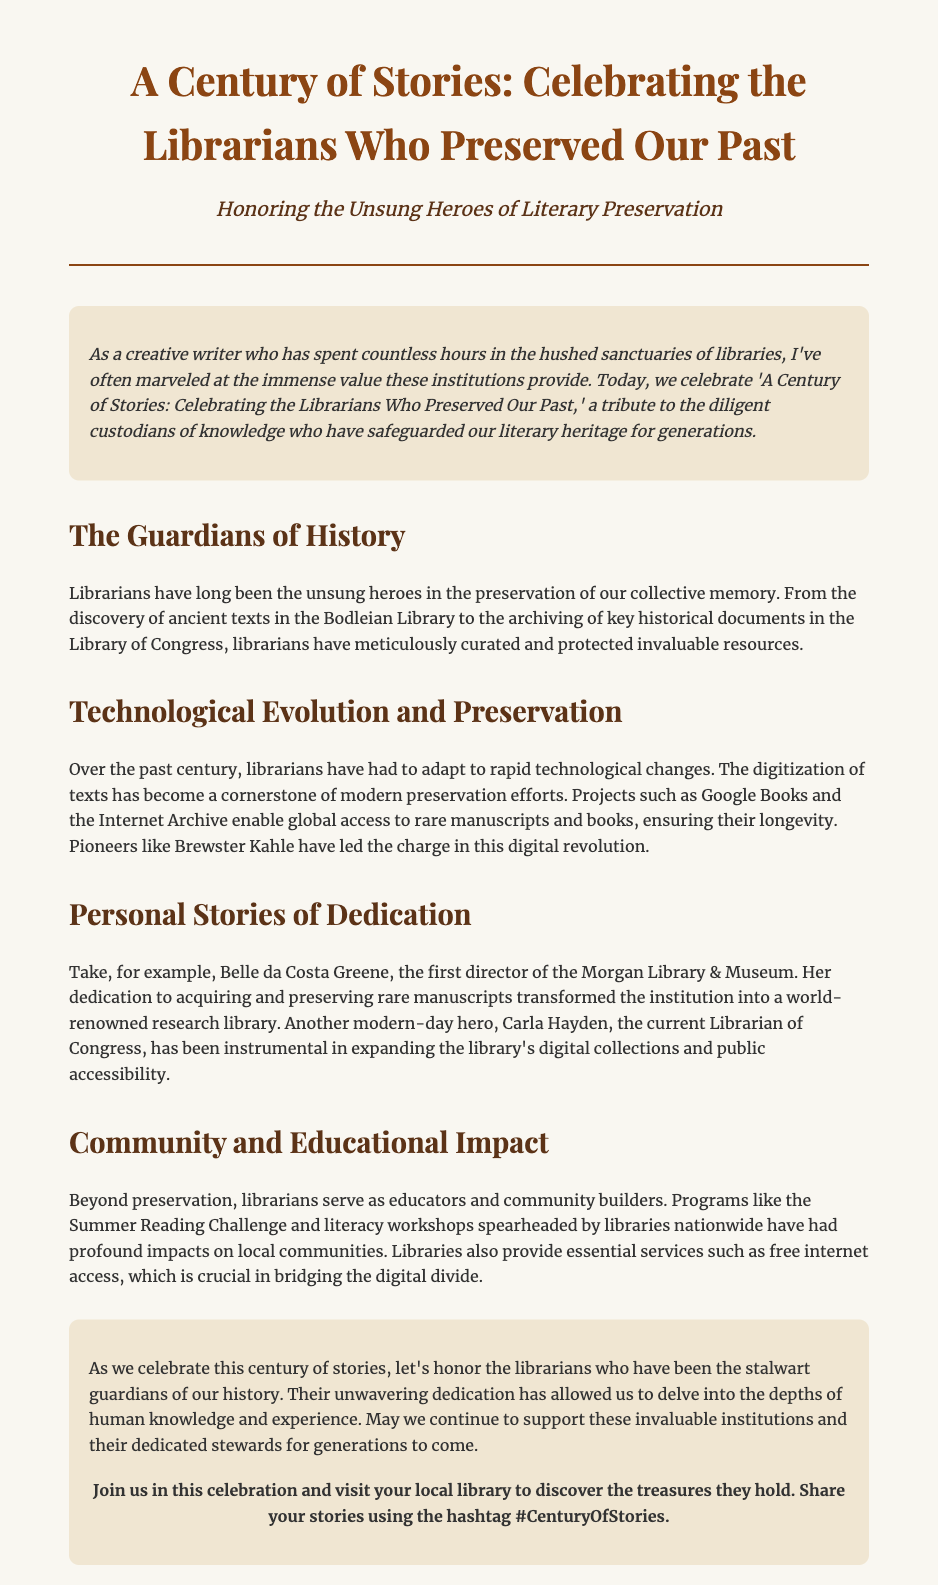What is the title of the press release? The title is presented prominently in the header section of the document.
Answer: A Century of Stories: Celebrating the Librarians Who Preserved Our Past Who is honored in this press release? The subtitle indicates that the focus is on librarians and their contributions.
Answer: The Unsung Heroes of Literary Preservation What modern project is mentioned for digitizing texts? The document references specific organizations involved in digitization efforts in the section about technological evolution.
Answer: Google Books Who was the first director of the Morgan Library & Museum? The body section about personal stories provides the name of an influential librarian.
Answer: Belle da Costa Greene What is the hashtag mentioned for sharing stories? The call-to-action section includes a prompt for sharing stories on social media.
Answer: #CenturyOfStories What service do libraries provide that bridges the digital divide? The document discusses essential services offered by libraries in relation to community support.
Answer: Free internet access How has Carla Hayden contributed to libraries? The body section on personal stories highlights her role in expanding digital collections.
Answer: Expanding digital collections What program is mentioned as having a profound impact on local communities? The body section on community impact notes a specific initiative led by libraries.
Answer: Summer Reading Challenge 